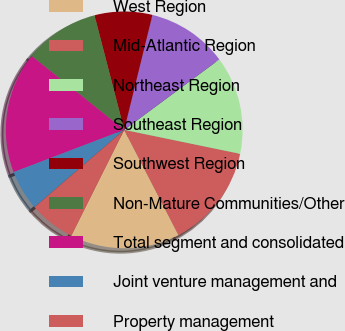Convert chart. <chart><loc_0><loc_0><loc_500><loc_500><pie_chart><fcel>West Region<fcel>Mid-Atlantic Region<fcel>Northeast Region<fcel>Southeast Region<fcel>Southwest Region<fcel>Non-Mature Communities/Other<fcel>Total segment and consolidated<fcel>Joint venture management and<fcel>Property management<nl><fcel>14.96%<fcel>14.17%<fcel>13.39%<fcel>11.02%<fcel>7.87%<fcel>10.24%<fcel>16.53%<fcel>5.51%<fcel>6.3%<nl></chart> 